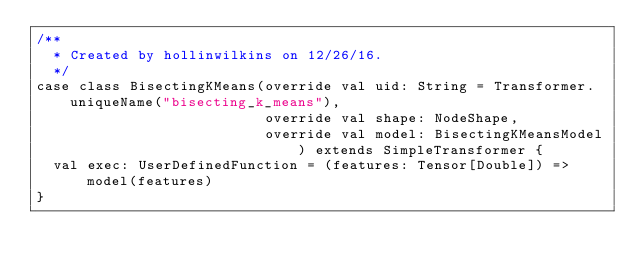<code> <loc_0><loc_0><loc_500><loc_500><_Scala_>/**
  * Created by hollinwilkins on 12/26/16.
  */
case class BisectingKMeans(override val uid: String = Transformer.uniqueName("bisecting_k_means"),
                           override val shape: NodeShape,
                           override val model: BisectingKMeansModel) extends SimpleTransformer {
  val exec: UserDefinedFunction = (features: Tensor[Double]) => model(features)
}
</code> 